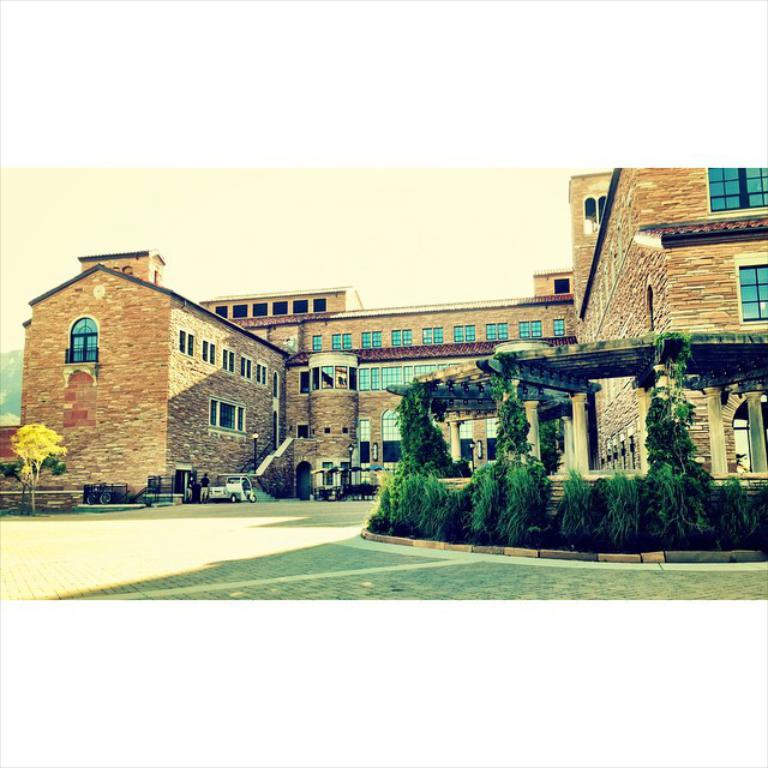What type of structure is visible in the image? There is a building in the image. What feature of the building is mentioned in the facts? The building has a group of windows. What can be seen on the right side of the image? There is a group of plants on the right side of the image. What is visible in the background of the image? The sky is visible in the background of the image. What channel is the building tuned to in the image? There is no indication of a channel or television in the image; it features a building with a group of windows and a group of plants on the right side. 